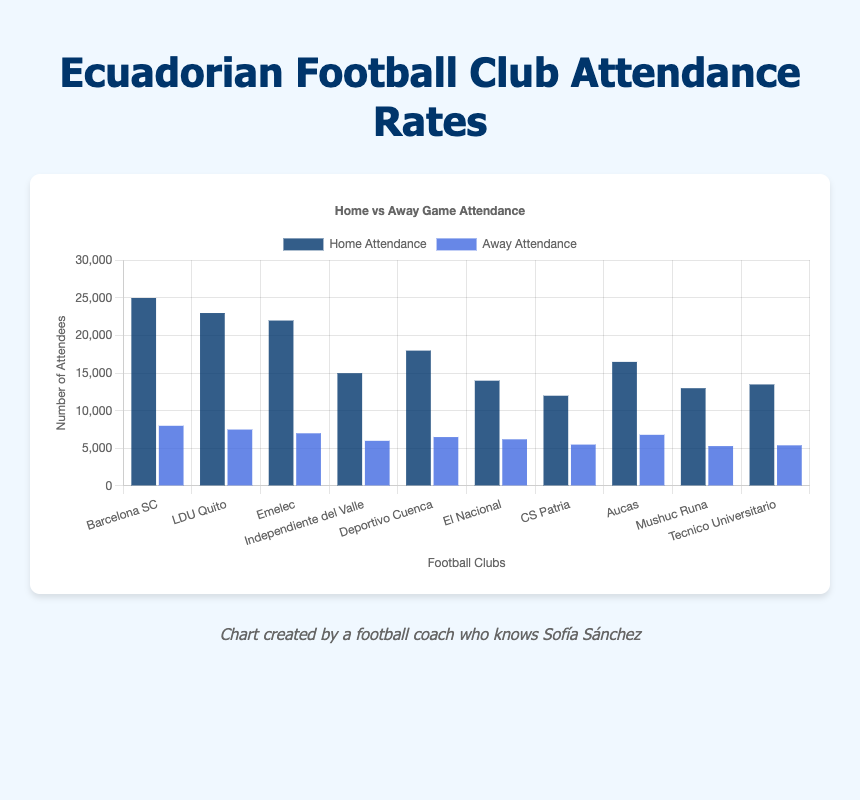Which club has the highest home game attendance? Check the data for each club and compare the home attendance figures. Barcelona SC has the highest home attendance at 25000.
Answer: Barcelona SC Which club has the lowest away game attendance? Review the data for away attendances and identify the smallest number, which is 5300 for Mushuc Runa.
Answer: Mushuc Runa What is the total attendance for home games across all clubs? Sum the home attendance values for all clubs: 25000 + 23000 + 22000 + 15000 + 18000 + 14000 + 12000 + 16500 + 13000 + 13500 = 172000.
Answer: 172000 How much higher is Barcelona SC's home attendance compared to Emelec's home attendance? Subtract Emelec's home attendance (22000) from Barcelona SC's home attendance (25000): 25000 - 22000 = 3000.
Answer: 3000 What is the difference in away game attendance between the club with the highest and the club with the lowest away attendance? Identify the highest away attendance (8000 - Barcelona SC) and the lowest (5300 - Mushuc Runa) and subtract: 8000 - 5300 = 2700.
Answer: 2700 Which club has a larger difference between home and away attendance, LDU Quito or Emelec? Calculate the difference for both clubs: LDU Quito (23000 - 7500 = 15500) and Emelec (22000 - 7000 = 15000) then compare: LDU Quito's difference is larger.
Answer: LDU Quito Compare the home and away attendance for Independiente del Valle visually, which bar is taller? By examining the chart, the home attendance bar for Independiente del Valle (15000) is significantly taller than the away attendance bar (6000).
Answer: Home attendance Which club has almost equal home and away game attendance? Look for clubs where the home and away attendance figures are close. CS Patria's figures are 12000 for home and 5500 for away.
Answer: None have nearly equal numbers, but CS Patria is fairly close Find the average away game attendance for all clubs. Sum all the away attendance values and divide by the number of clubs: (8000 + 7500 + 7000 + 6000 + 6500 + 6200 + 5500 + 6800 + 5300 + 5400) / 10 = 6420.
Answer: 6420 Which club has the highest combined (home + away) attendance? Calculate the combined attendance for each club and identify the highest: Barcelona SC with (25000 + 8000 = 33000).
Answer: Barcelona SC 